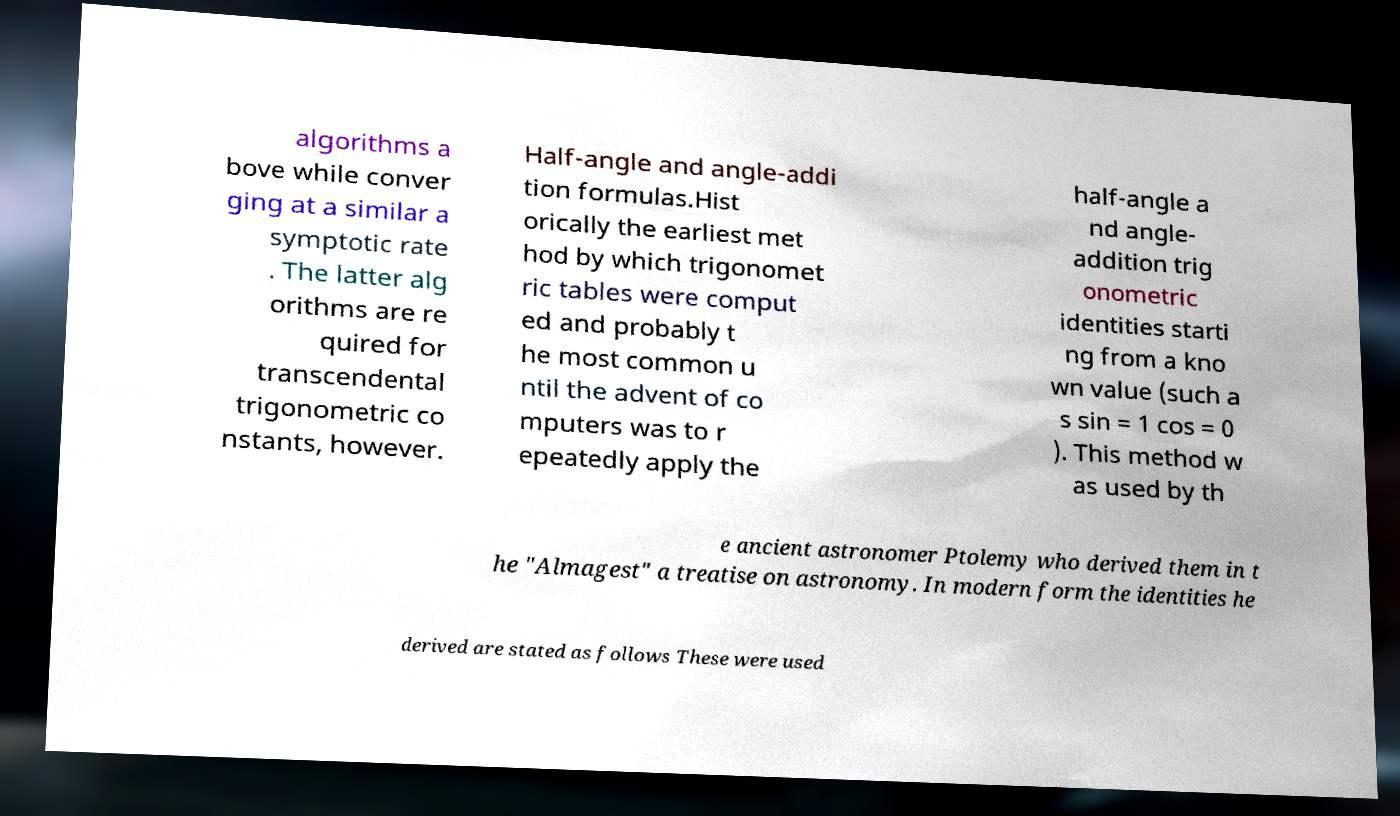For documentation purposes, I need the text within this image transcribed. Could you provide that? algorithms a bove while conver ging at a similar a symptotic rate . The latter alg orithms are re quired for transcendental trigonometric co nstants, however. Half-angle and angle-addi tion formulas.Hist orically the earliest met hod by which trigonomet ric tables were comput ed and probably t he most common u ntil the advent of co mputers was to r epeatedly apply the half-angle a nd angle- addition trig onometric identities starti ng from a kno wn value (such a s sin = 1 cos = 0 ). This method w as used by th e ancient astronomer Ptolemy who derived them in t he "Almagest" a treatise on astronomy. In modern form the identities he derived are stated as follows These were used 